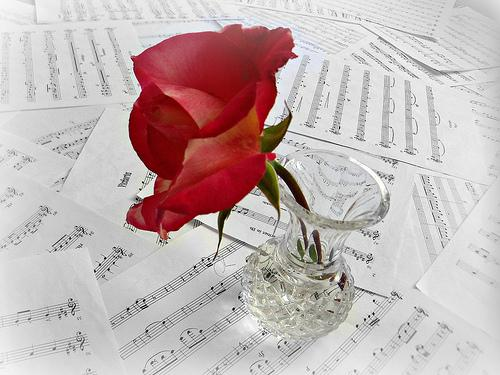Analyze the interactions between the various objects mentioned in the image descriptions. The red rose with green stem and leaves sits inside the clear crystal vase with water, and the vase rests on the scattered white music sheets with black writing, signifying a harmonious balance of elegance and artistry. Comment on any details you can observe about the object that holds the flower and what it is placed on. The urn-shaped crystal vase has an uneven diamond cut pattern, is half filled with water, and rests on scattered white music sheets with black writing. How would you interpret the overall emotion presented in the image? The image conveys an elegant and artistic feel with the combination of a red rose, a crystal vase, and scattered music sheets. Specify the color of a particular object and its state, and identify any other object it is interacting with. The red rose with green stem and leaves appears slightly wilted and is sitting in a clear crystal vase on top of music sheets. Provide a concise summary highlighting the central elements of the image. An open red rose in a glass vase with diamond cut pattern, filled partly with water, sits on an array of scattered music sheets. Assess the quality of the image based on how well the objects are represented and captured. The quality of the image is good, presenting clear and detailed objects such as the red petals, the crystal vase, and the music sheets. Count the number of different objects mentioned in the captions and identify them. There are five different objects: one red rose, one clear crystal vase, the water inside the vase, the stem and leaves of the flower, and the scattered music sheets. Briefly describe the primary object in the picture and mention any other object it is connected to. The main object is a red rose placed inside a clear, fancy crystal vase half filled with water on scattered music sheets. Perform a complex reasoning task by identifying any unique detail about the way the flower and vase are presented. The red rose appears to be slightly wilted, and the crystal vase holding it has a unique diamond cut out pattern, possibly indicating the passage of time and fragility of beauty. What can you infer about the relationship between the rose and the music sheets in this image? The placement of the red rose in the vase on the music sheets signifies a blend of beauty and artistic expression, evoking a sense of elegance. 